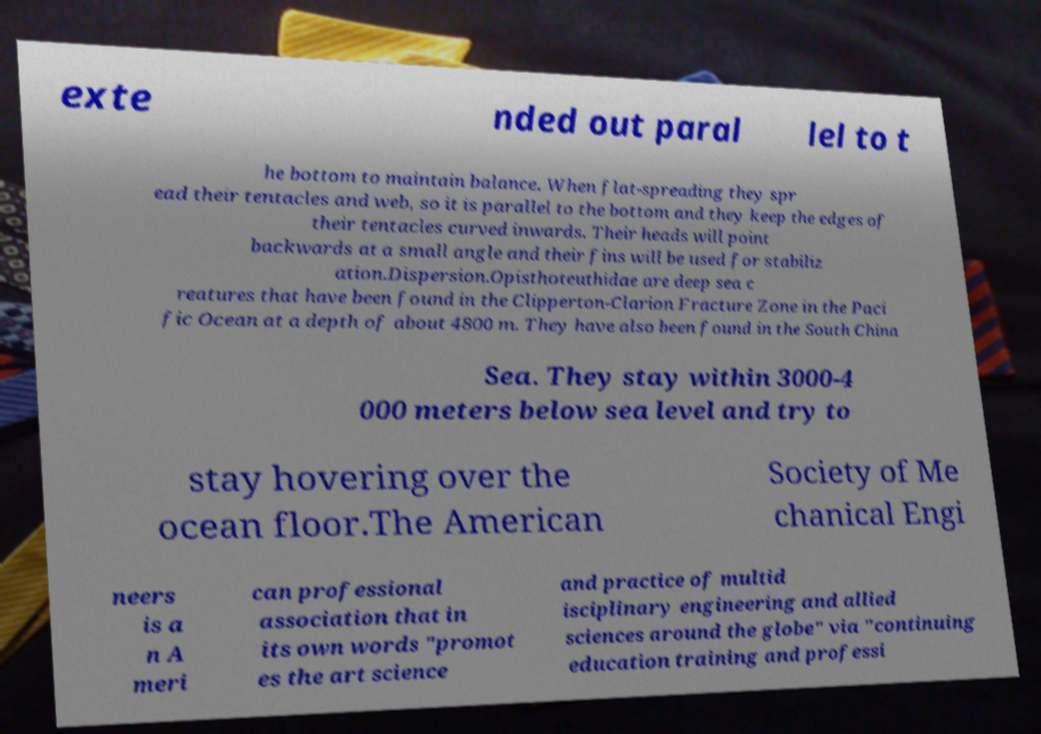For documentation purposes, I need the text within this image transcribed. Could you provide that? exte nded out paral lel to t he bottom to maintain balance. When flat-spreading they spr ead their tentacles and web, so it is parallel to the bottom and they keep the edges of their tentacles curved inwards. Their heads will point backwards at a small angle and their fins will be used for stabiliz ation.Dispersion.Opisthoteuthidae are deep sea c reatures that have been found in the Clipperton-Clarion Fracture Zone in the Paci fic Ocean at a depth of about 4800 m. They have also been found in the South China Sea. They stay within 3000-4 000 meters below sea level and try to stay hovering over the ocean floor.The American Society of Me chanical Engi neers is a n A meri can professional association that in its own words "promot es the art science and practice of multid isciplinary engineering and allied sciences around the globe" via "continuing education training and professi 